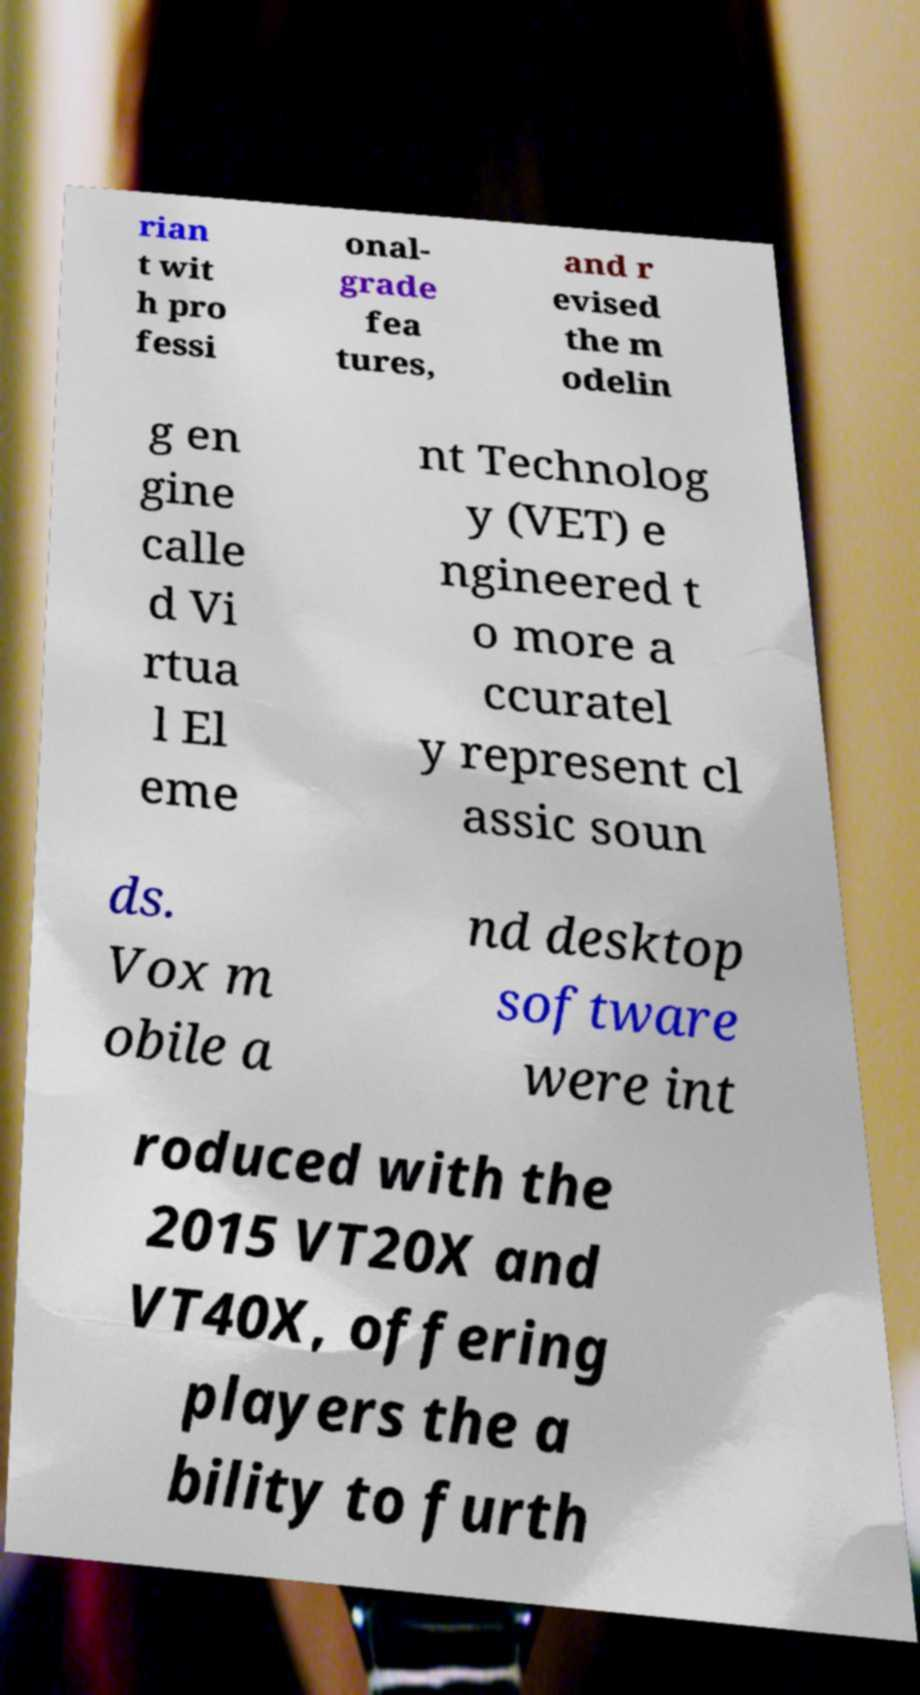Can you accurately transcribe the text from the provided image for me? rian t wit h pro fessi onal- grade fea tures, and r evised the m odelin g en gine calle d Vi rtua l El eme nt Technolog y (VET) e ngineered t o more a ccuratel y represent cl assic soun ds. Vox m obile a nd desktop software were int roduced with the 2015 VT20X and VT40X, offering players the a bility to furth 